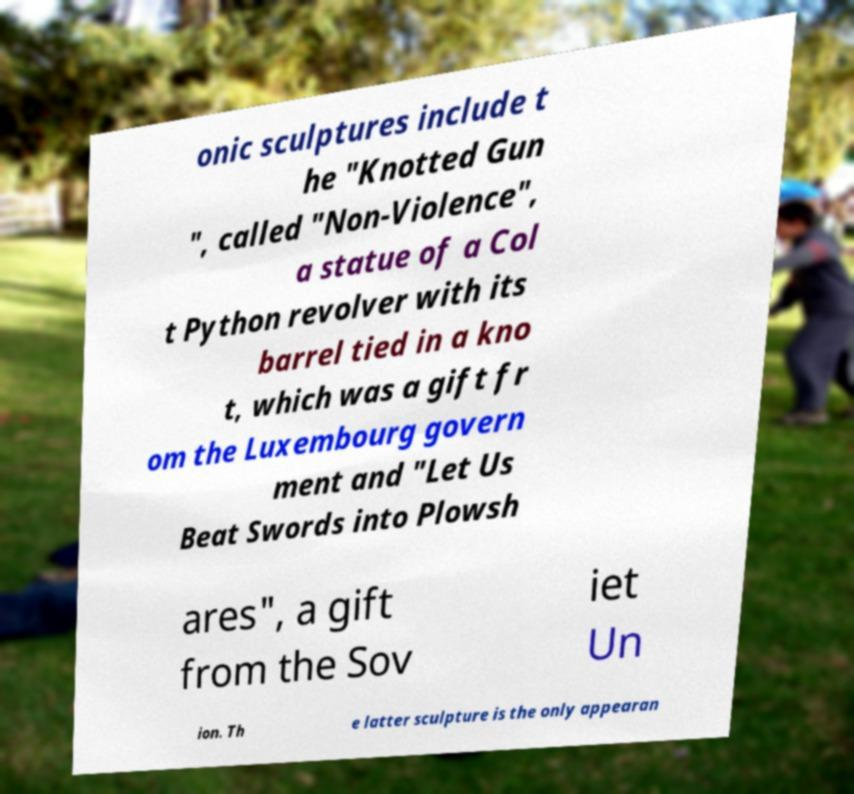I need the written content from this picture converted into text. Can you do that? onic sculptures include t he "Knotted Gun ", called "Non-Violence", a statue of a Col t Python revolver with its barrel tied in a kno t, which was a gift fr om the Luxembourg govern ment and "Let Us Beat Swords into Plowsh ares", a gift from the Sov iet Un ion. Th e latter sculpture is the only appearan 